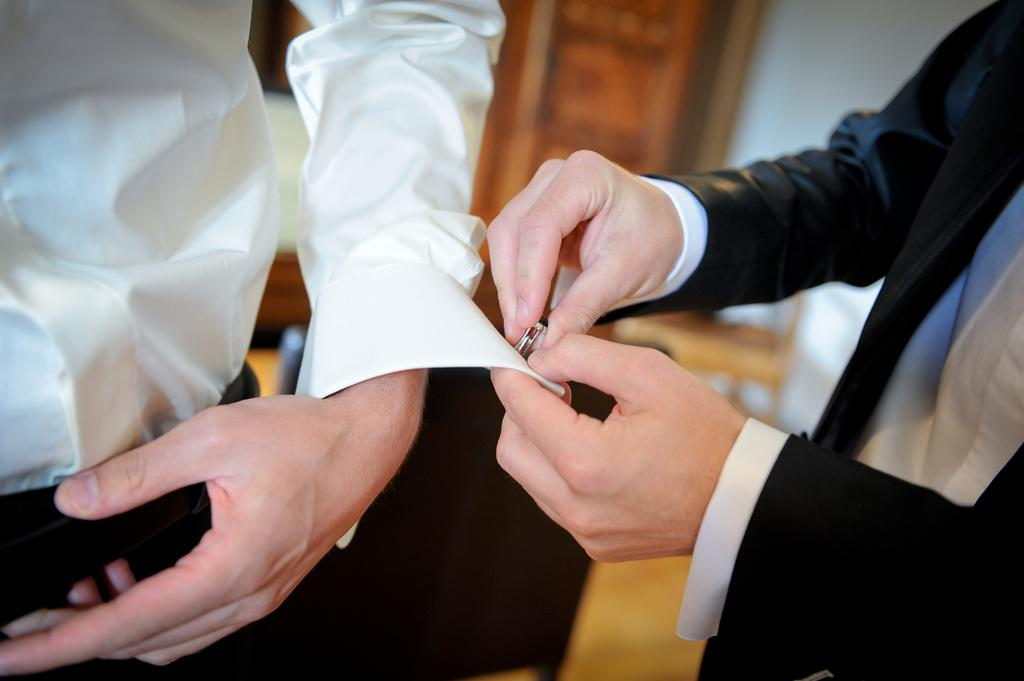How many people are in the image? There are two persons in the image. What are the people wearing? Both persons are wearing white shirts. What is one of the persons holding? One of the persons is holding a button. What can be seen in the background of the image? There is a wall in the background of the image. What is visible beneath the people in the image? There is a floor visible in the image. What type of cream can be seen on the crow's feathers in the image? There is no crow or cream present in the image. 